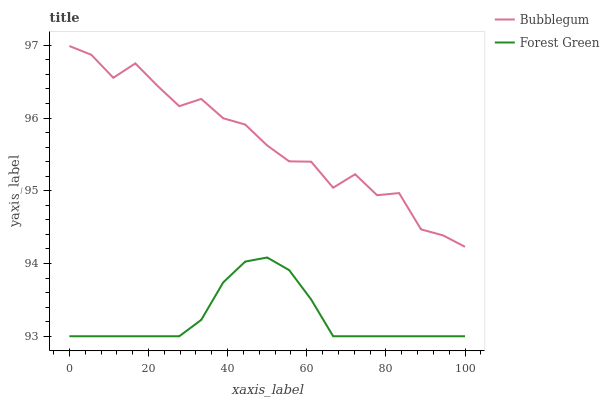Does Forest Green have the minimum area under the curve?
Answer yes or no. Yes. Does Bubblegum have the maximum area under the curve?
Answer yes or no. Yes. Does Bubblegum have the minimum area under the curve?
Answer yes or no. No. Is Forest Green the smoothest?
Answer yes or no. Yes. Is Bubblegum the roughest?
Answer yes or no. Yes. Is Bubblegum the smoothest?
Answer yes or no. No. Does Bubblegum have the lowest value?
Answer yes or no. No. Does Bubblegum have the highest value?
Answer yes or no. Yes. Is Forest Green less than Bubblegum?
Answer yes or no. Yes. Is Bubblegum greater than Forest Green?
Answer yes or no. Yes. Does Forest Green intersect Bubblegum?
Answer yes or no. No. 